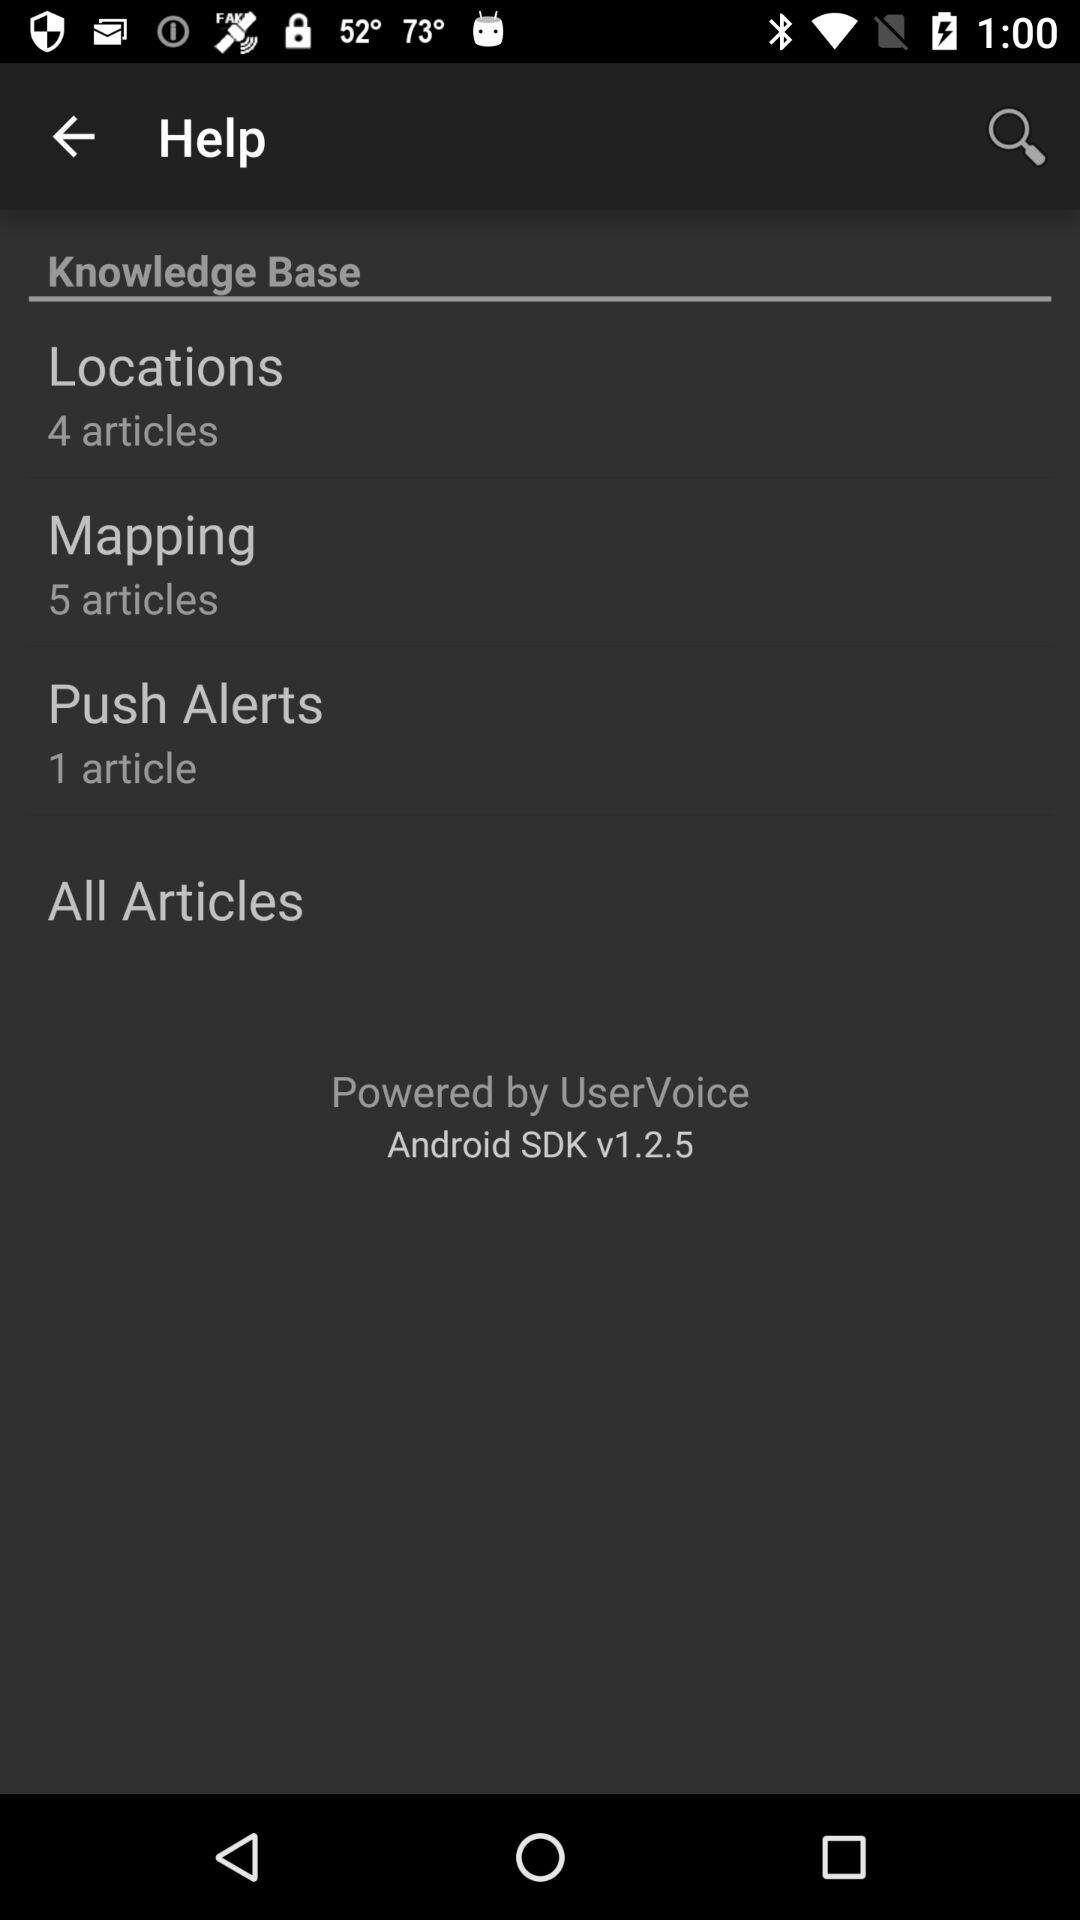How many articles are there in the Mapping category?
Answer the question using a single word or phrase. 5 